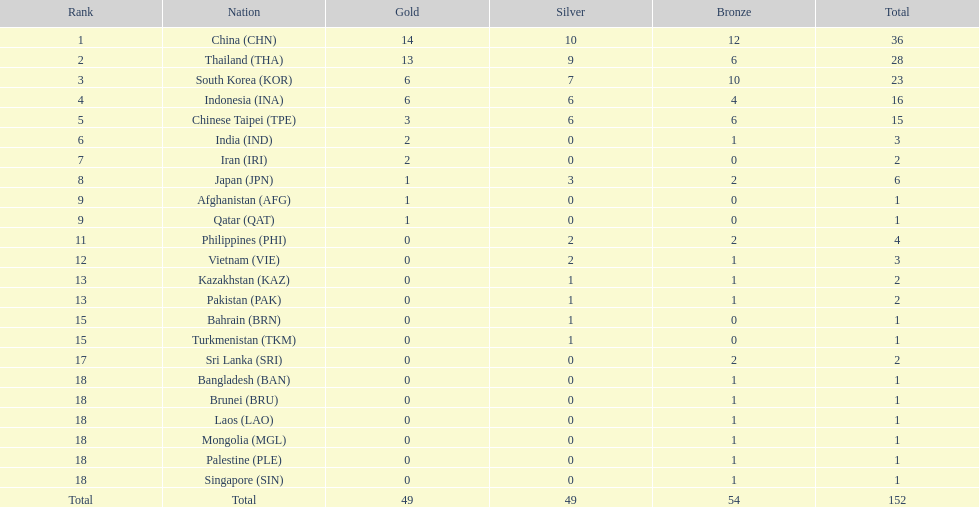How many nations received more than 5 gold medals? 4. 